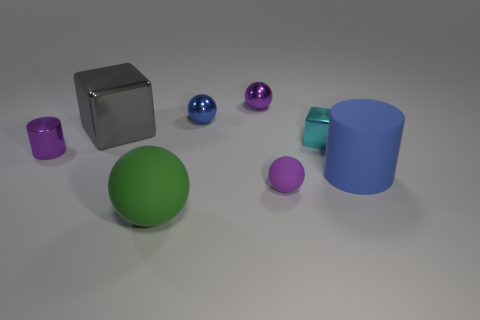Are there the same number of gray things that are behind the small rubber thing and small spheres?
Your response must be concise. No. How many other small rubber things are the same shape as the tiny cyan thing?
Offer a very short reply. 0. What size is the shiny sphere that is behind the blue shiny thing to the left of the big rubber object that is to the right of the cyan shiny object?
Your answer should be compact. Small. Are the purple object in front of the big blue cylinder and the big sphere made of the same material?
Your answer should be very brief. Yes. Is the number of green objects in front of the big gray metallic block the same as the number of large metal objects that are to the right of the tiny blue object?
Provide a succinct answer. No. Is there any other thing that has the same size as the purple rubber object?
Make the answer very short. Yes. What is the material of the other thing that is the same shape as the cyan metallic object?
Your answer should be compact. Metal. There is a matte thing left of the tiny purple shiny thing to the right of the blue sphere; is there a small blue metallic object to the left of it?
Offer a terse response. No. There is a purple metallic thing behind the cyan shiny thing; does it have the same shape as the tiny rubber thing that is in front of the tiny purple shiny cylinder?
Keep it short and to the point. Yes. Are there more cyan metal objects that are in front of the matte cylinder than large metal things?
Your answer should be compact. No. 